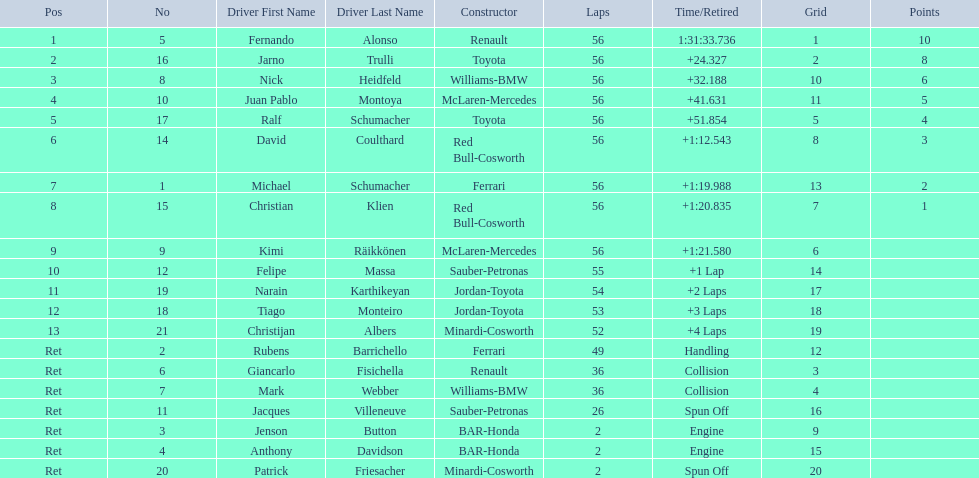Who was fernando alonso's instructor? Renault. How many laps did fernando alonso run? 56. How long did it take alonso to complete the race? 1:31:33.736. 